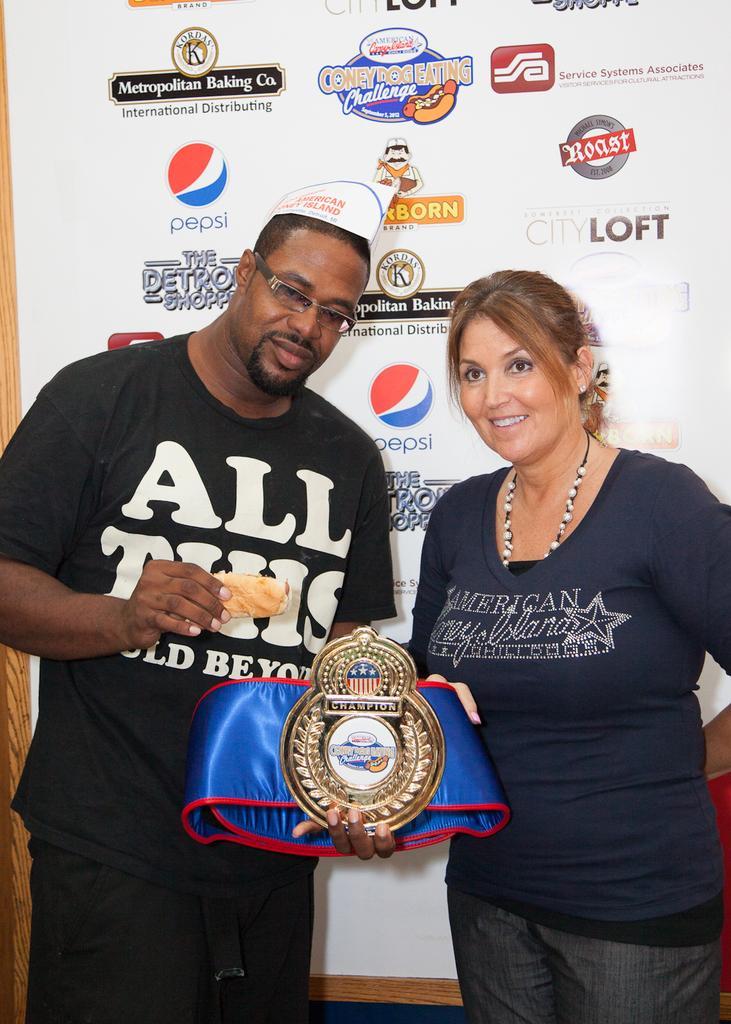How would you summarize this image in a sentence or two? In this image I can see two people. These people are holding the shield and the cloth which is in blue and red color. These people are wearing the navy blue color dress. In the back I can see the board which is colorful. 